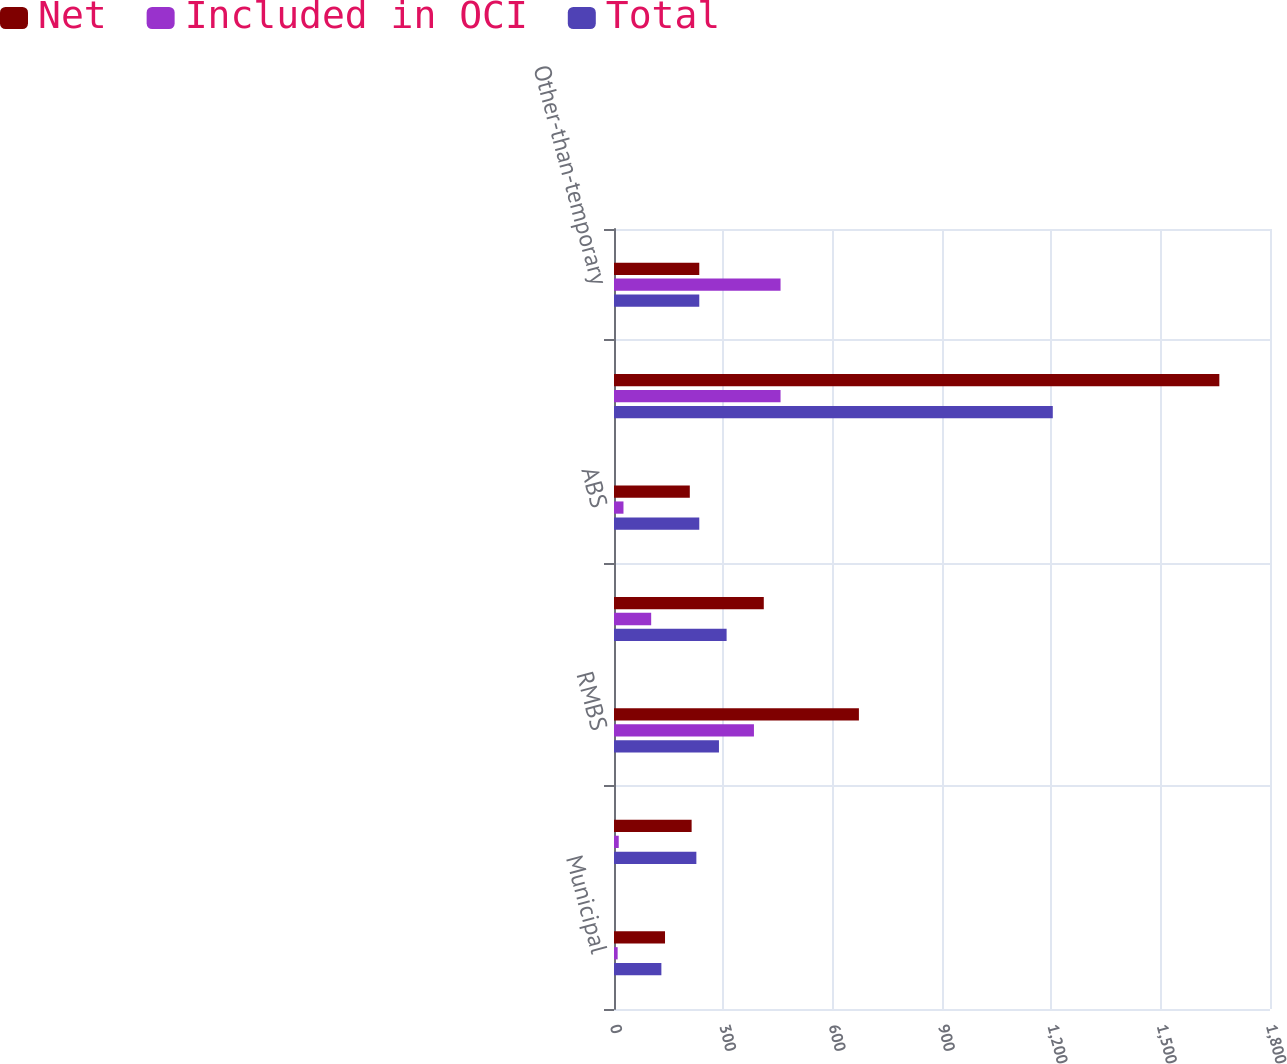Convert chart. <chart><loc_0><loc_0><loc_500><loc_500><stacked_bar_chart><ecel><fcel>Municipal<fcel>Corporate<fcel>RMBS<fcel>CMBS<fcel>ABS<fcel>Total fixed income securities<fcel>Other-than-temporary<nl><fcel>Net<fcel>140<fcel>213<fcel>672<fcel>411<fcel>208<fcel>1661<fcel>234<nl><fcel>Included in OCI<fcel>10<fcel>13<fcel>384<fcel>102<fcel>26<fcel>457<fcel>457<nl><fcel>Total<fcel>130<fcel>226<fcel>288<fcel>309<fcel>234<fcel>1204<fcel>234<nl></chart> 